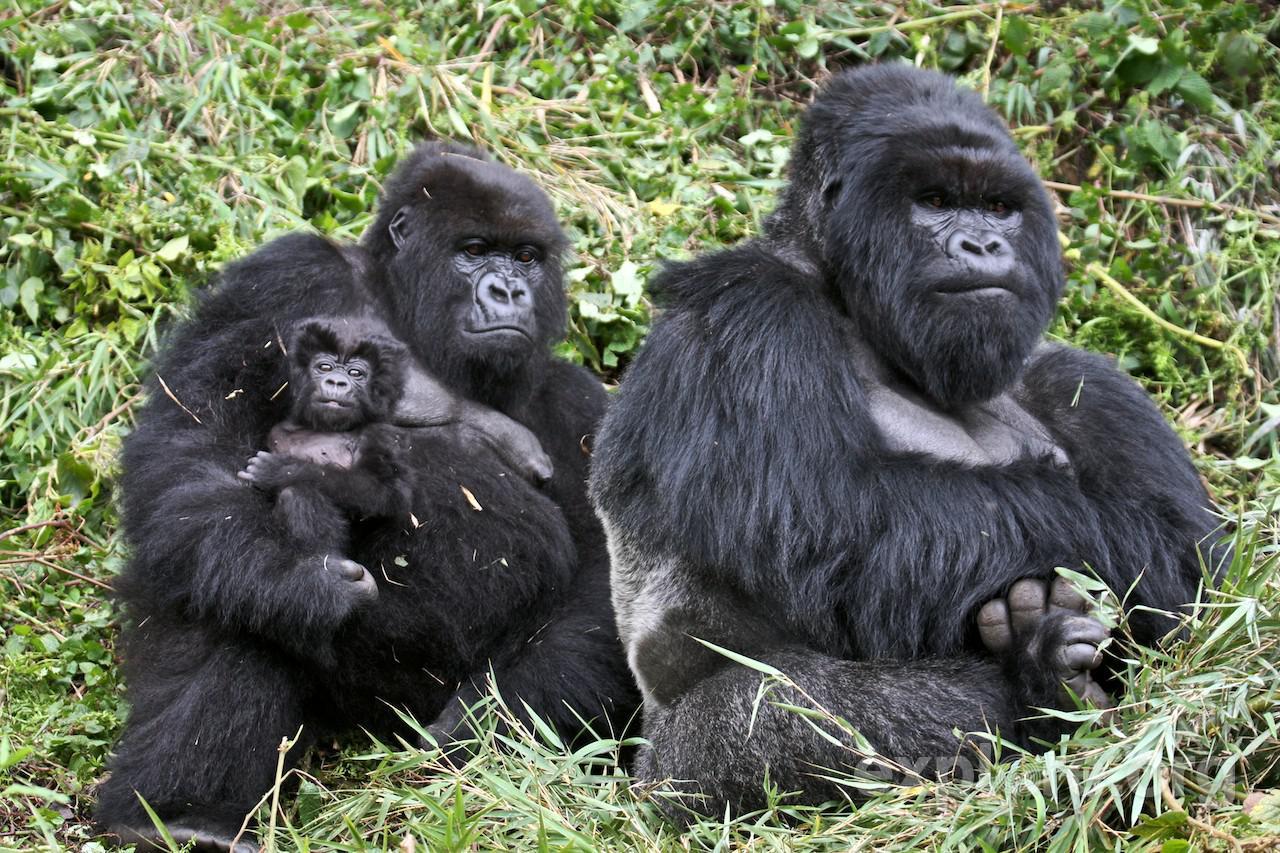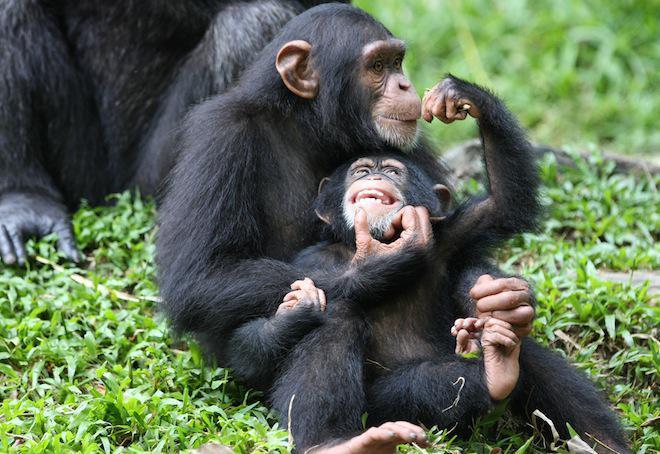The first image is the image on the left, the second image is the image on the right. Considering the images on both sides, is "At least one of the images contains exactly three monkeys." valid? Answer yes or no. Yes. 